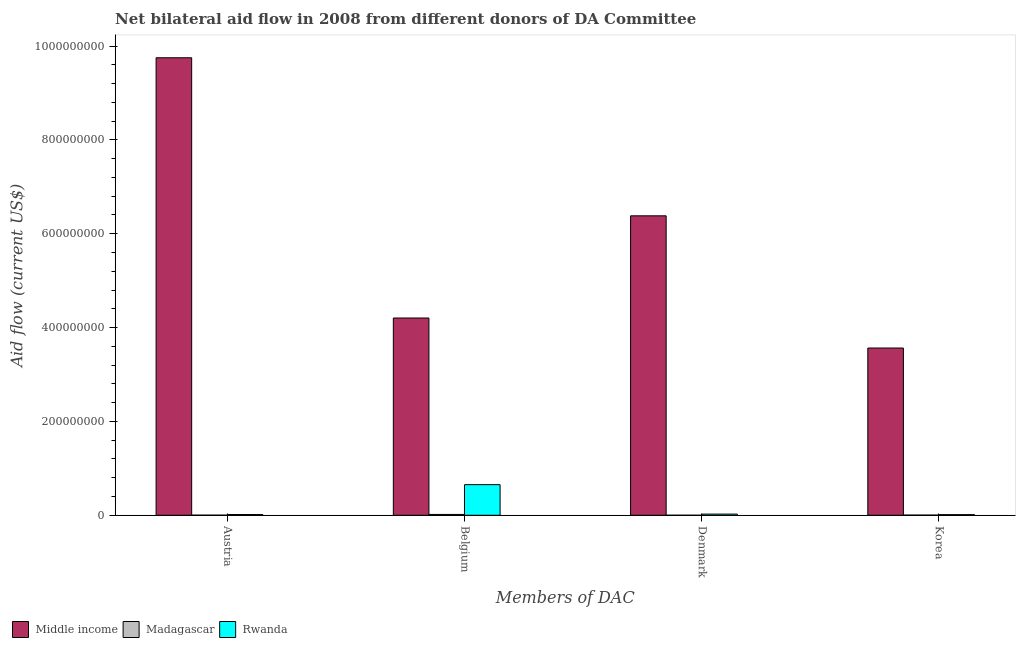How many different coloured bars are there?
Provide a succinct answer. 3. How many groups of bars are there?
Your response must be concise. 4. Are the number of bars per tick equal to the number of legend labels?
Provide a succinct answer. Yes. How many bars are there on the 3rd tick from the left?
Your answer should be very brief. 3. How many bars are there on the 2nd tick from the right?
Provide a short and direct response. 3. What is the label of the 3rd group of bars from the left?
Offer a terse response. Denmark. What is the amount of aid given by austria in Middle income?
Provide a succinct answer. 9.75e+08. Across all countries, what is the maximum amount of aid given by austria?
Ensure brevity in your answer.  9.75e+08. Across all countries, what is the minimum amount of aid given by korea?
Your answer should be compact. 3.10e+05. In which country was the amount of aid given by austria minimum?
Offer a very short reply. Madagascar. What is the total amount of aid given by denmark in the graph?
Make the answer very short. 6.41e+08. What is the difference between the amount of aid given by belgium in Rwanda and that in Madagascar?
Keep it short and to the point. 6.35e+07. What is the difference between the amount of aid given by korea in Rwanda and the amount of aid given by austria in Middle income?
Your answer should be compact. -9.74e+08. What is the average amount of aid given by denmark per country?
Provide a succinct answer. 2.14e+08. What is the difference between the amount of aid given by austria and amount of aid given by belgium in Middle income?
Give a very brief answer. 5.55e+08. In how many countries, is the amount of aid given by austria greater than 760000000 US$?
Ensure brevity in your answer.  1. What is the ratio of the amount of aid given by austria in Rwanda to that in Middle income?
Provide a succinct answer. 0. Is the amount of aid given by belgium in Middle income less than that in Madagascar?
Give a very brief answer. No. Is the difference between the amount of aid given by denmark in Middle income and Rwanda greater than the difference between the amount of aid given by korea in Middle income and Rwanda?
Your answer should be compact. Yes. What is the difference between the highest and the second highest amount of aid given by belgium?
Keep it short and to the point. 3.55e+08. What is the difference between the highest and the lowest amount of aid given by denmark?
Keep it short and to the point. 6.38e+08. In how many countries, is the amount of aid given by austria greater than the average amount of aid given by austria taken over all countries?
Offer a very short reply. 1. Is the sum of the amount of aid given by austria in Middle income and Rwanda greater than the maximum amount of aid given by denmark across all countries?
Offer a very short reply. Yes. Is it the case that in every country, the sum of the amount of aid given by korea and amount of aid given by austria is greater than the sum of amount of aid given by belgium and amount of aid given by denmark?
Your answer should be compact. No. What does the 3rd bar from the left in Denmark represents?
Ensure brevity in your answer.  Rwanda. What does the 1st bar from the right in Denmark represents?
Provide a succinct answer. Rwanda. How many countries are there in the graph?
Keep it short and to the point. 3. What is the difference between two consecutive major ticks on the Y-axis?
Your response must be concise. 2.00e+08. Are the values on the major ticks of Y-axis written in scientific E-notation?
Provide a succinct answer. No. Does the graph contain any zero values?
Your response must be concise. No. Where does the legend appear in the graph?
Your response must be concise. Bottom left. How many legend labels are there?
Your response must be concise. 3. What is the title of the graph?
Provide a succinct answer. Net bilateral aid flow in 2008 from different donors of DA Committee. What is the label or title of the X-axis?
Give a very brief answer. Members of DAC. What is the Aid flow (current US$) in Middle income in Austria?
Make the answer very short. 9.75e+08. What is the Aid flow (current US$) of Rwanda in Austria?
Your answer should be compact. 1.55e+06. What is the Aid flow (current US$) in Middle income in Belgium?
Offer a very short reply. 4.20e+08. What is the Aid flow (current US$) in Madagascar in Belgium?
Keep it short and to the point. 1.77e+06. What is the Aid flow (current US$) of Rwanda in Belgium?
Offer a terse response. 6.52e+07. What is the Aid flow (current US$) in Middle income in Denmark?
Ensure brevity in your answer.  6.38e+08. What is the Aid flow (current US$) of Rwanda in Denmark?
Offer a terse response. 2.46e+06. What is the Aid flow (current US$) in Middle income in Korea?
Provide a succinct answer. 3.56e+08. What is the Aid flow (current US$) of Madagascar in Korea?
Provide a short and direct response. 3.10e+05. What is the Aid flow (current US$) of Rwanda in Korea?
Provide a short and direct response. 1.35e+06. Across all Members of DAC, what is the maximum Aid flow (current US$) of Middle income?
Offer a terse response. 9.75e+08. Across all Members of DAC, what is the maximum Aid flow (current US$) in Madagascar?
Provide a short and direct response. 1.77e+06. Across all Members of DAC, what is the maximum Aid flow (current US$) in Rwanda?
Provide a short and direct response. 6.52e+07. Across all Members of DAC, what is the minimum Aid flow (current US$) in Middle income?
Ensure brevity in your answer.  3.56e+08. Across all Members of DAC, what is the minimum Aid flow (current US$) of Rwanda?
Keep it short and to the point. 1.35e+06. What is the total Aid flow (current US$) in Middle income in the graph?
Provide a short and direct response. 2.39e+09. What is the total Aid flow (current US$) of Madagascar in the graph?
Make the answer very short. 2.26e+06. What is the total Aid flow (current US$) of Rwanda in the graph?
Make the answer very short. 7.06e+07. What is the difference between the Aid flow (current US$) in Middle income in Austria and that in Belgium?
Make the answer very short. 5.55e+08. What is the difference between the Aid flow (current US$) of Madagascar in Austria and that in Belgium?
Keep it short and to the point. -1.60e+06. What is the difference between the Aid flow (current US$) in Rwanda in Austria and that in Belgium?
Provide a short and direct response. -6.37e+07. What is the difference between the Aid flow (current US$) in Middle income in Austria and that in Denmark?
Provide a succinct answer. 3.37e+08. What is the difference between the Aid flow (current US$) in Rwanda in Austria and that in Denmark?
Keep it short and to the point. -9.10e+05. What is the difference between the Aid flow (current US$) of Middle income in Austria and that in Korea?
Offer a terse response. 6.19e+08. What is the difference between the Aid flow (current US$) in Rwanda in Austria and that in Korea?
Keep it short and to the point. 2.00e+05. What is the difference between the Aid flow (current US$) of Middle income in Belgium and that in Denmark?
Give a very brief answer. -2.18e+08. What is the difference between the Aid flow (current US$) of Madagascar in Belgium and that in Denmark?
Your answer should be compact. 1.76e+06. What is the difference between the Aid flow (current US$) in Rwanda in Belgium and that in Denmark?
Your answer should be compact. 6.28e+07. What is the difference between the Aid flow (current US$) in Middle income in Belgium and that in Korea?
Make the answer very short. 6.40e+07. What is the difference between the Aid flow (current US$) of Madagascar in Belgium and that in Korea?
Provide a short and direct response. 1.46e+06. What is the difference between the Aid flow (current US$) of Rwanda in Belgium and that in Korea?
Your answer should be very brief. 6.39e+07. What is the difference between the Aid flow (current US$) of Middle income in Denmark and that in Korea?
Your answer should be very brief. 2.82e+08. What is the difference between the Aid flow (current US$) in Rwanda in Denmark and that in Korea?
Your response must be concise. 1.11e+06. What is the difference between the Aid flow (current US$) of Middle income in Austria and the Aid flow (current US$) of Madagascar in Belgium?
Make the answer very short. 9.73e+08. What is the difference between the Aid flow (current US$) of Middle income in Austria and the Aid flow (current US$) of Rwanda in Belgium?
Offer a very short reply. 9.10e+08. What is the difference between the Aid flow (current US$) of Madagascar in Austria and the Aid flow (current US$) of Rwanda in Belgium?
Ensure brevity in your answer.  -6.51e+07. What is the difference between the Aid flow (current US$) of Middle income in Austria and the Aid flow (current US$) of Madagascar in Denmark?
Keep it short and to the point. 9.75e+08. What is the difference between the Aid flow (current US$) of Middle income in Austria and the Aid flow (current US$) of Rwanda in Denmark?
Your answer should be compact. 9.73e+08. What is the difference between the Aid flow (current US$) of Madagascar in Austria and the Aid flow (current US$) of Rwanda in Denmark?
Give a very brief answer. -2.29e+06. What is the difference between the Aid flow (current US$) of Middle income in Austria and the Aid flow (current US$) of Madagascar in Korea?
Offer a very short reply. 9.75e+08. What is the difference between the Aid flow (current US$) in Middle income in Austria and the Aid flow (current US$) in Rwanda in Korea?
Offer a terse response. 9.74e+08. What is the difference between the Aid flow (current US$) of Madagascar in Austria and the Aid flow (current US$) of Rwanda in Korea?
Offer a terse response. -1.18e+06. What is the difference between the Aid flow (current US$) in Middle income in Belgium and the Aid flow (current US$) in Madagascar in Denmark?
Offer a very short reply. 4.20e+08. What is the difference between the Aid flow (current US$) in Middle income in Belgium and the Aid flow (current US$) in Rwanda in Denmark?
Offer a very short reply. 4.18e+08. What is the difference between the Aid flow (current US$) in Madagascar in Belgium and the Aid flow (current US$) in Rwanda in Denmark?
Provide a succinct answer. -6.90e+05. What is the difference between the Aid flow (current US$) in Middle income in Belgium and the Aid flow (current US$) in Madagascar in Korea?
Give a very brief answer. 4.20e+08. What is the difference between the Aid flow (current US$) of Middle income in Belgium and the Aid flow (current US$) of Rwanda in Korea?
Provide a short and direct response. 4.19e+08. What is the difference between the Aid flow (current US$) in Middle income in Denmark and the Aid flow (current US$) in Madagascar in Korea?
Your answer should be compact. 6.38e+08. What is the difference between the Aid flow (current US$) of Middle income in Denmark and the Aid flow (current US$) of Rwanda in Korea?
Make the answer very short. 6.37e+08. What is the difference between the Aid flow (current US$) of Madagascar in Denmark and the Aid flow (current US$) of Rwanda in Korea?
Give a very brief answer. -1.34e+06. What is the average Aid flow (current US$) of Middle income per Members of DAC?
Offer a terse response. 5.98e+08. What is the average Aid flow (current US$) of Madagascar per Members of DAC?
Make the answer very short. 5.65e+05. What is the average Aid flow (current US$) of Rwanda per Members of DAC?
Your answer should be compact. 1.76e+07. What is the difference between the Aid flow (current US$) of Middle income and Aid flow (current US$) of Madagascar in Austria?
Make the answer very short. 9.75e+08. What is the difference between the Aid flow (current US$) of Middle income and Aid flow (current US$) of Rwanda in Austria?
Your answer should be very brief. 9.74e+08. What is the difference between the Aid flow (current US$) in Madagascar and Aid flow (current US$) in Rwanda in Austria?
Offer a very short reply. -1.38e+06. What is the difference between the Aid flow (current US$) of Middle income and Aid flow (current US$) of Madagascar in Belgium?
Your answer should be compact. 4.19e+08. What is the difference between the Aid flow (current US$) in Middle income and Aid flow (current US$) in Rwanda in Belgium?
Your response must be concise. 3.55e+08. What is the difference between the Aid flow (current US$) of Madagascar and Aid flow (current US$) of Rwanda in Belgium?
Keep it short and to the point. -6.35e+07. What is the difference between the Aid flow (current US$) of Middle income and Aid flow (current US$) of Madagascar in Denmark?
Provide a succinct answer. 6.38e+08. What is the difference between the Aid flow (current US$) of Middle income and Aid flow (current US$) of Rwanda in Denmark?
Provide a succinct answer. 6.36e+08. What is the difference between the Aid flow (current US$) in Madagascar and Aid flow (current US$) in Rwanda in Denmark?
Your response must be concise. -2.45e+06. What is the difference between the Aid flow (current US$) of Middle income and Aid flow (current US$) of Madagascar in Korea?
Ensure brevity in your answer.  3.56e+08. What is the difference between the Aid flow (current US$) in Middle income and Aid flow (current US$) in Rwanda in Korea?
Your response must be concise. 3.55e+08. What is the difference between the Aid flow (current US$) of Madagascar and Aid flow (current US$) of Rwanda in Korea?
Provide a succinct answer. -1.04e+06. What is the ratio of the Aid flow (current US$) of Middle income in Austria to that in Belgium?
Provide a succinct answer. 2.32. What is the ratio of the Aid flow (current US$) in Madagascar in Austria to that in Belgium?
Give a very brief answer. 0.1. What is the ratio of the Aid flow (current US$) in Rwanda in Austria to that in Belgium?
Ensure brevity in your answer.  0.02. What is the ratio of the Aid flow (current US$) of Middle income in Austria to that in Denmark?
Your answer should be very brief. 1.53. What is the ratio of the Aid flow (current US$) in Rwanda in Austria to that in Denmark?
Your answer should be compact. 0.63. What is the ratio of the Aid flow (current US$) of Middle income in Austria to that in Korea?
Your answer should be compact. 2.74. What is the ratio of the Aid flow (current US$) in Madagascar in Austria to that in Korea?
Your response must be concise. 0.55. What is the ratio of the Aid flow (current US$) in Rwanda in Austria to that in Korea?
Offer a very short reply. 1.15. What is the ratio of the Aid flow (current US$) of Middle income in Belgium to that in Denmark?
Make the answer very short. 0.66. What is the ratio of the Aid flow (current US$) of Madagascar in Belgium to that in Denmark?
Your answer should be very brief. 177. What is the ratio of the Aid flow (current US$) of Rwanda in Belgium to that in Denmark?
Ensure brevity in your answer.  26.52. What is the ratio of the Aid flow (current US$) of Middle income in Belgium to that in Korea?
Offer a terse response. 1.18. What is the ratio of the Aid flow (current US$) in Madagascar in Belgium to that in Korea?
Provide a short and direct response. 5.71. What is the ratio of the Aid flow (current US$) in Rwanda in Belgium to that in Korea?
Your response must be concise. 48.33. What is the ratio of the Aid flow (current US$) of Middle income in Denmark to that in Korea?
Your response must be concise. 1.79. What is the ratio of the Aid flow (current US$) in Madagascar in Denmark to that in Korea?
Provide a succinct answer. 0.03. What is the ratio of the Aid flow (current US$) of Rwanda in Denmark to that in Korea?
Make the answer very short. 1.82. What is the difference between the highest and the second highest Aid flow (current US$) in Middle income?
Offer a terse response. 3.37e+08. What is the difference between the highest and the second highest Aid flow (current US$) in Madagascar?
Keep it short and to the point. 1.46e+06. What is the difference between the highest and the second highest Aid flow (current US$) of Rwanda?
Your answer should be compact. 6.28e+07. What is the difference between the highest and the lowest Aid flow (current US$) in Middle income?
Give a very brief answer. 6.19e+08. What is the difference between the highest and the lowest Aid flow (current US$) in Madagascar?
Give a very brief answer. 1.76e+06. What is the difference between the highest and the lowest Aid flow (current US$) in Rwanda?
Ensure brevity in your answer.  6.39e+07. 